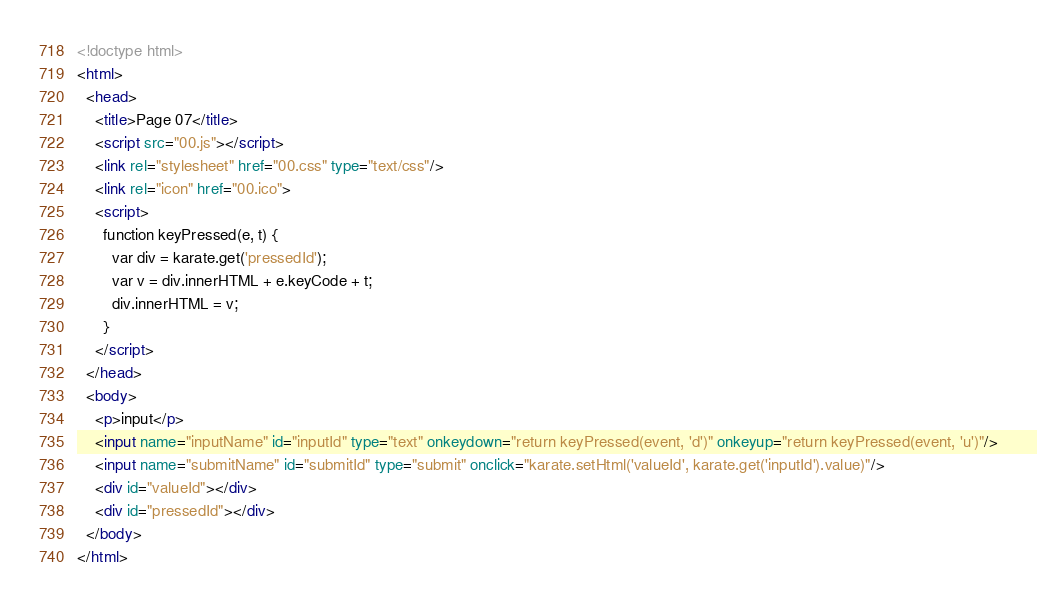<code> <loc_0><loc_0><loc_500><loc_500><_HTML_><!doctype html>
<html>
  <head>
    <title>Page 07</title>
    <script src="00.js"></script>
    <link rel="stylesheet" href="00.css" type="text/css"/>  
    <link rel="icon" href="00.ico">
    <script>
      function keyPressed(e, t) {
        var div = karate.get('pressedId');
        var v = div.innerHTML + e.keyCode + t;
        div.innerHTML = v;
      }
    </script>
  </head>
  <body>
    <p>input</p>
    <input name="inputName" id="inputId" type="text" onkeydown="return keyPressed(event, 'd')" onkeyup="return keyPressed(event, 'u')"/>
    <input name="submitName" id="submitId" type="submit" onclick="karate.setHtml('valueId', karate.get('inputId').value)"/>
    <div id="valueId"></div>
    <div id="pressedId"></div>
  </body>
</html>
</code> 